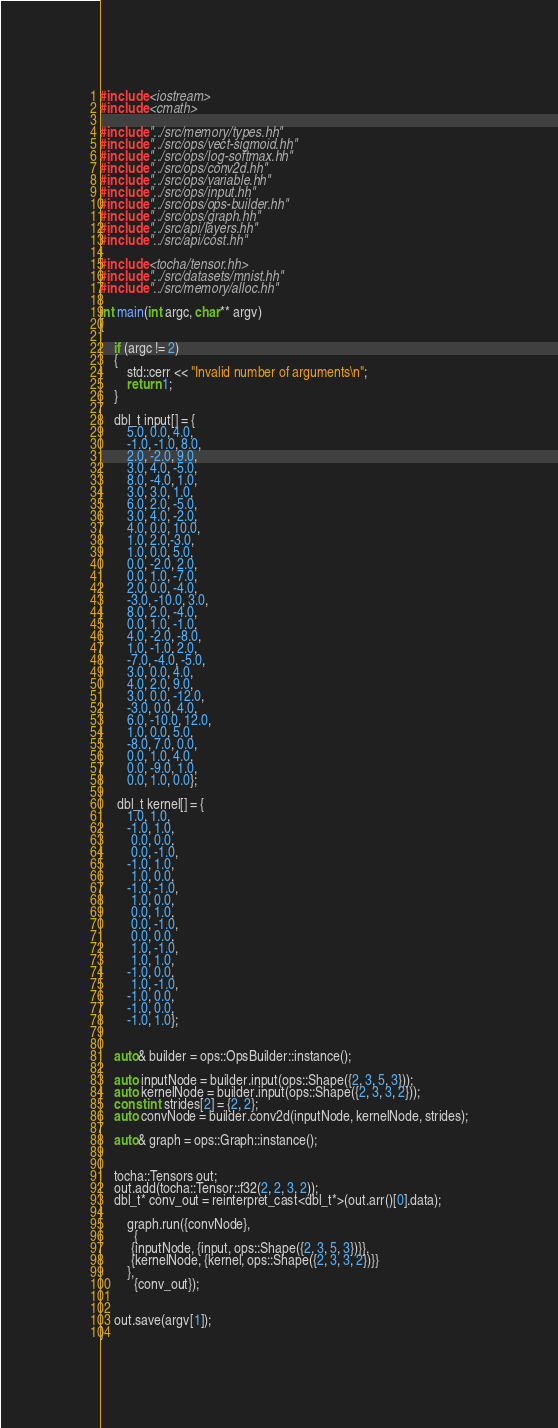Convert code to text. <code><loc_0><loc_0><loc_500><loc_500><_Cuda_>#include <iostream>
#include <cmath>

#include "../src/memory/types.hh"
#include "../src/ops/vect-sigmoid.hh"
#include "../src/ops/log-softmax.hh"
#include "../src/ops/conv2d.hh"
#include "../src/ops/variable.hh"
#include "../src/ops/input.hh"
#include "../src/ops/ops-builder.hh"
#include "../src/ops/graph.hh"
#include "../src/api/layers.hh"
#include "../src/api/cost.hh"

#include <tocha/tensor.hh>
#include "../src/datasets/mnist.hh"
#include "../src/memory/alloc.hh"

int main(int argc, char** argv)
{

    if (argc != 2)
    {
        std::cerr << "Invalid number of arguments\n";
        return 1;
    }

    dbl_t input[] = {
        5.0, 0.0, 4.0,
        -1.0, -1.0, 8.0,
        2.0, -2.0, 9.0,
        3.0, 4.0, -5.0,
        8.0, -4.0, 1.0,
        3.0, 3.0, 1.0,
        6.0, 2.0, -5.0,
        3.0, 4.0, -2.0,
        4.0, 0.0, 10.0,
        1.0, 2.0,-3.0,
        1.0, 0.0, 5.0,
        0.0, -2.0, 2.0,
        0.0, 1.0, -7.0,
        2.0, 0.0, -4.0,
        -3.0, -10.0, 3.0,
        8.0, 2.0, -4.0,
        0.0, 1.0, -1.0,
        4.0, -2.0, -8.0,
        1.0, -1.0, 2.0,
        -7.0, -4.0, -5.0,
        3.0, 0.0, 4.0,
        4.0, 2.0, 9.0,
        3.0, 0.0, -12.0,
        -3.0, 0.0, 4.0,
        6.0, -10.0, 12.0,
        1.0, 0.0, 5.0,
        -8.0, 7.0, 0.0,
        0.0, 1.0, 4.0,
        0.0, -9.0, 1.0,
        0.0, 1.0, 0.0};

     dbl_t kernel[] = {
        1.0, 1.0,
        -1.0, 1.0,
         0.0, 0.0,
         0.0, -1.0,
        -1.0, 1.0,
         1.0, 0.0,
        -1.0, -1.0,
         1.0, 0.0,
         0.0, 1.0,
         0.0, -1.0,
         0.0, 0.0,
         1.0, -1.0,
         1.0, 1.0,
        -1.0, 0.0,
         1.0, -1.0,
        -1.0, 0.0,
        -1.0, 0.0,
        -1.0, 1.0};


    auto& builder = ops::OpsBuilder::instance();

    auto inputNode = builder.input(ops::Shape({2, 3, 5, 3}));
    auto kernelNode = builder.input(ops::Shape({2, 3, 3, 2}));
    const int strides[2] = {2, 2};
    auto convNode = builder.conv2d(inputNode, kernelNode, strides);

    auto& graph = ops::Graph::instance();


    tocha::Tensors out;
    out.add(tocha::Tensor::f32(2, 2, 3, 2));
    dbl_t* conv_out = reinterpret_cast<dbl_t*>(out.arr()[0].data);

        graph.run({convNode},
	      {
         {inputNode, {input, ops::Shape({2, 3, 5, 3})}},
         {kernelNode, {kernel, ops::Shape({2, 3, 3, 2})}}
        },
	      {conv_out});


    out.save(argv[1]);
}
</code> 